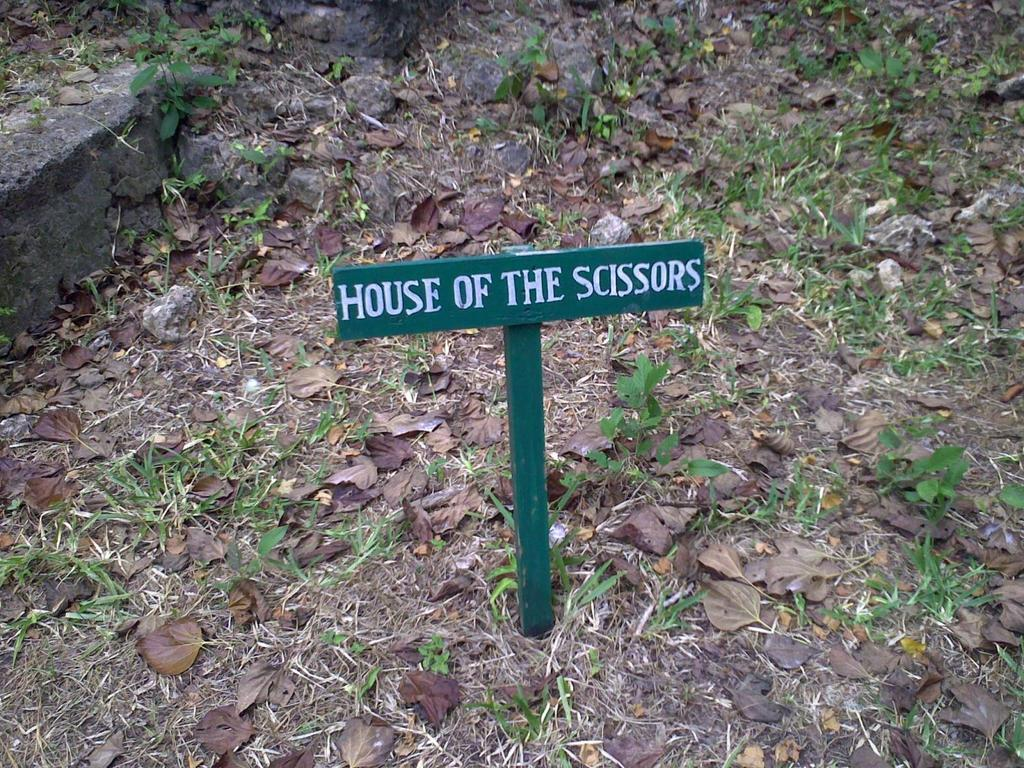What is on the board that is visible in the image? There is text on the board in the image. What type of natural environment is depicted in the image? There is grass in the image, which suggests a natural outdoor setting. What else can be seen on the surface in the image? There are leaves on the surface in the image. How many sticks are visible in the image? There is no stick present in the image. What type of haircut does the bee have in the image? There is no bee present in the image, so it is not possible to determine its haircut. 